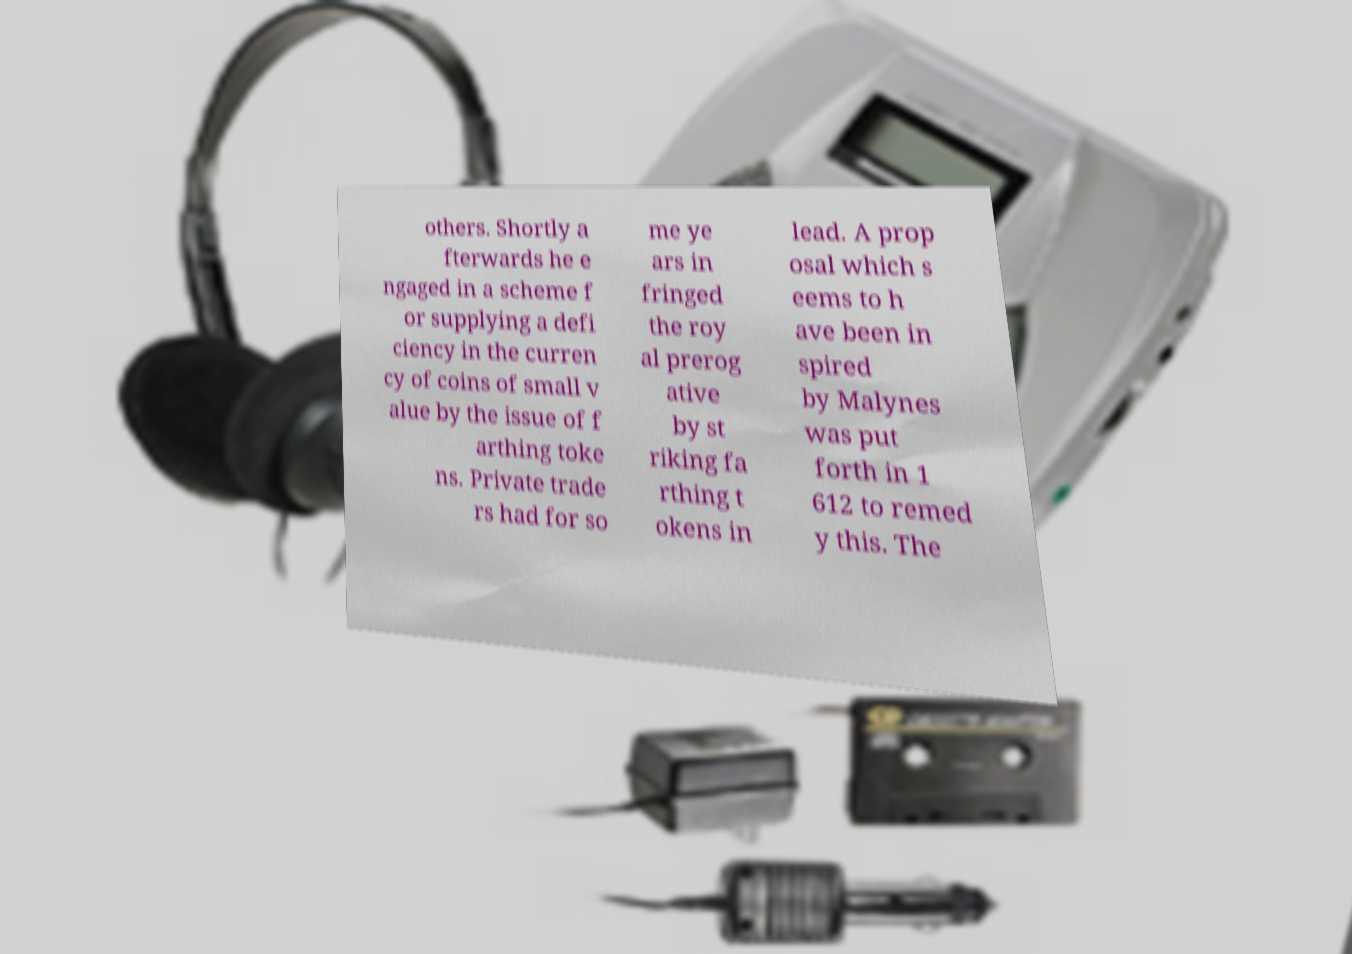I need the written content from this picture converted into text. Can you do that? others. Shortly a fterwards he e ngaged in a scheme f or supplying a defi ciency in the curren cy of coins of small v alue by the issue of f arthing toke ns. Private trade rs had for so me ye ars in fringed the roy al prerog ative by st riking fa rthing t okens in lead. A prop osal which s eems to h ave been in spired by Malynes was put forth in 1 612 to remed y this. The 